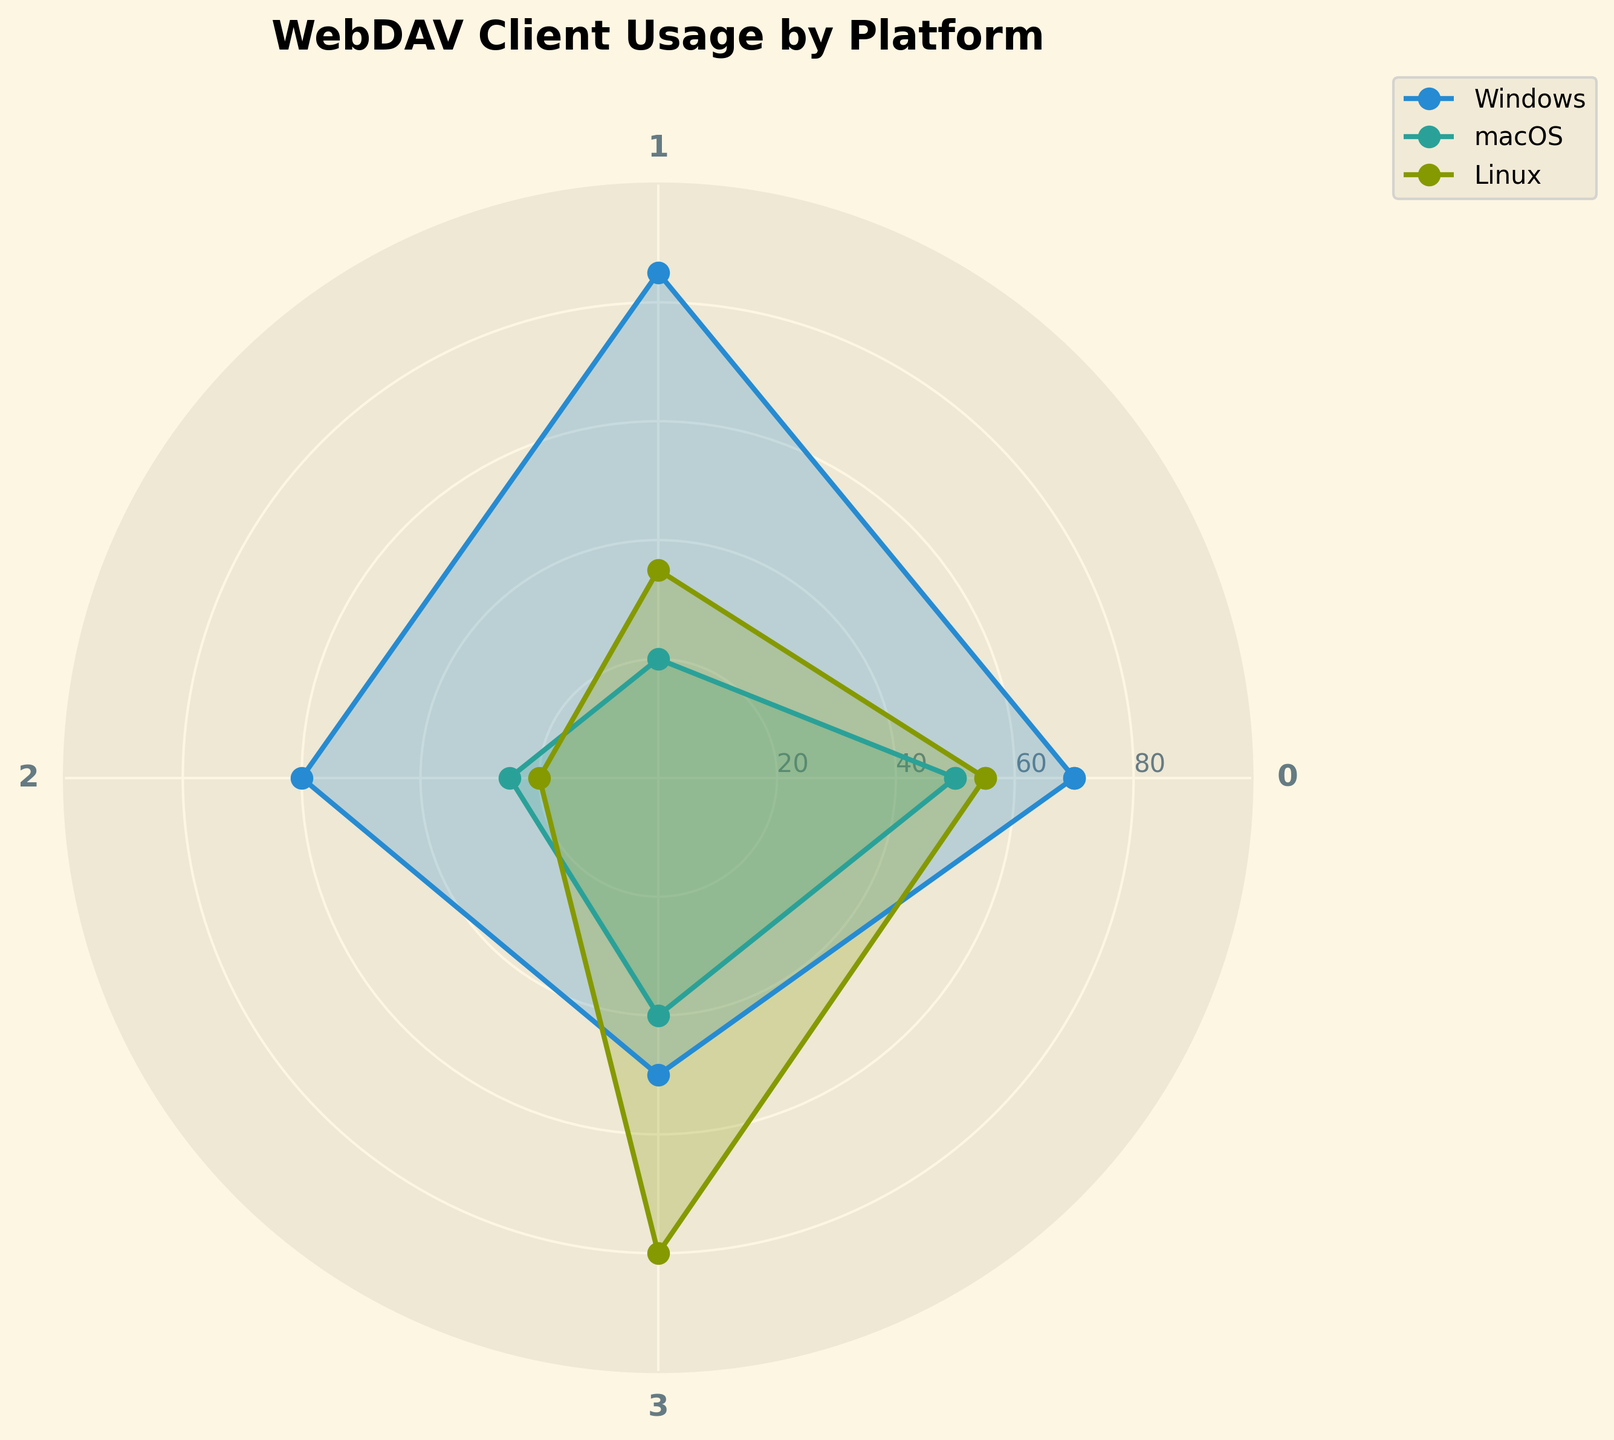What is the title of the radar chart? The title of the chart is typically prominent at the top and easily identifiable. In this chart, the title is shown at the very top in bold.
Answer: WebDAV Client Usage by Platform Which WebDAV client has the highest usage on Windows? To determine the highest usage, look for the longest line segment in the Windows section of the radar chart. The segment with the highest value represents the client with the highest usage.
Answer: WinSCP Which platform shows the lowest usage for BitKinex? For BitKinex, check the length of the respective line segments for each platform. The shortest segment indicates the lowest usage.
Answer: Linux What is the average usage of Cyberduck across the three platforms? To find the average usage, sum up the values for Cyberduck across all platforms (70+50+55) and then divide by the number of platforms (3).
Answer: 58.33 On which platform does Dolphin have the highest usage? Compare the segments for Dolphin across all platforms. The longest segment indicates the platform with the highest usage.
Answer: Linux For which WebDAV client is there the smallest difference in usage between Windows and macOS? Calculate the absolute difference between the Windows and macOS values for each client. The client with the smallest difference is the answer. Differences: Cyberduck (20), WinSCP (65), BitKinex (35), Dolphin (10).
Answer: Dolphin Which platform has the most balanced usage among all WebDAV clients? Check the radar chart for the platform where the lines are more evenly spread out around the center, indicating balanced usage.
Answer: macOS What would be the median value of usage for WinSCP across all platforms? Arrange the WinSCP usage values in increasing order (20, 35, 85). The median is the middle number in this ordered list.
Answer: 35 Is there any WebDAV client that has a higher usage on Linux than on macOS and Windows? Compare the respective values for all clients. Only Dolphin has higher usage on Linux (80) than on both macOS (40) and Windows (50).
Answer: Yes, Dolphin How does the usage of Cyberduck on macOS compare to its usage on Linux? Compare the values of Cyberduck on macOS (50) and Linux (55).
Answer: Cyberduck has slightly lower usage on macOS than on Linux 